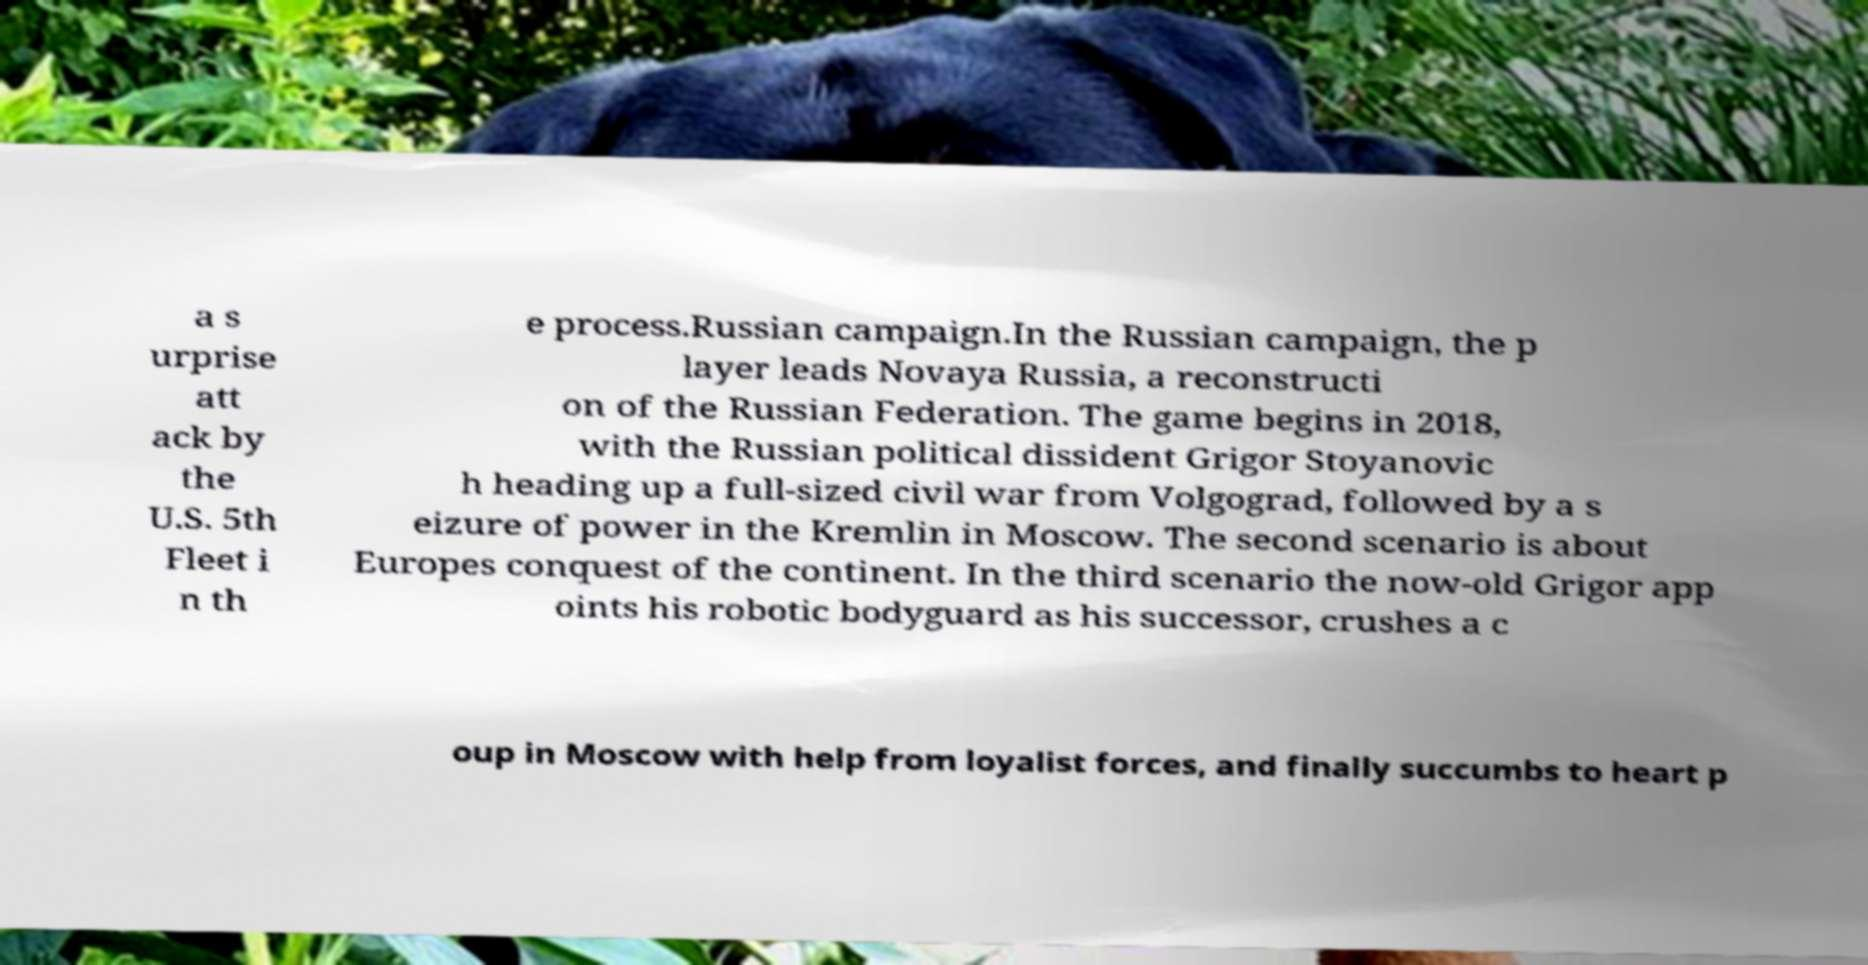Please identify and transcribe the text found in this image. a s urprise att ack by the U.S. 5th Fleet i n th e process.Russian campaign.In the Russian campaign, the p layer leads Novaya Russia, a reconstructi on of the Russian Federation. The game begins in 2018, with the Russian political dissident Grigor Stoyanovic h heading up a full-sized civil war from Volgograd, followed by a s eizure of power in the Kremlin in Moscow. The second scenario is about Europes conquest of the continent. In the third scenario the now-old Grigor app oints his robotic bodyguard as his successor, crushes a c oup in Moscow with help from loyalist forces, and finally succumbs to heart p 